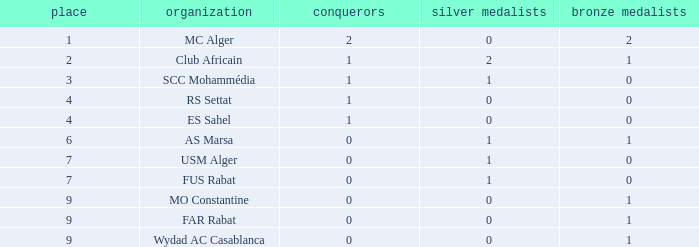Which Winners is the highest one that has a Rank larger than 7, and a Third smaller than 1? None. 